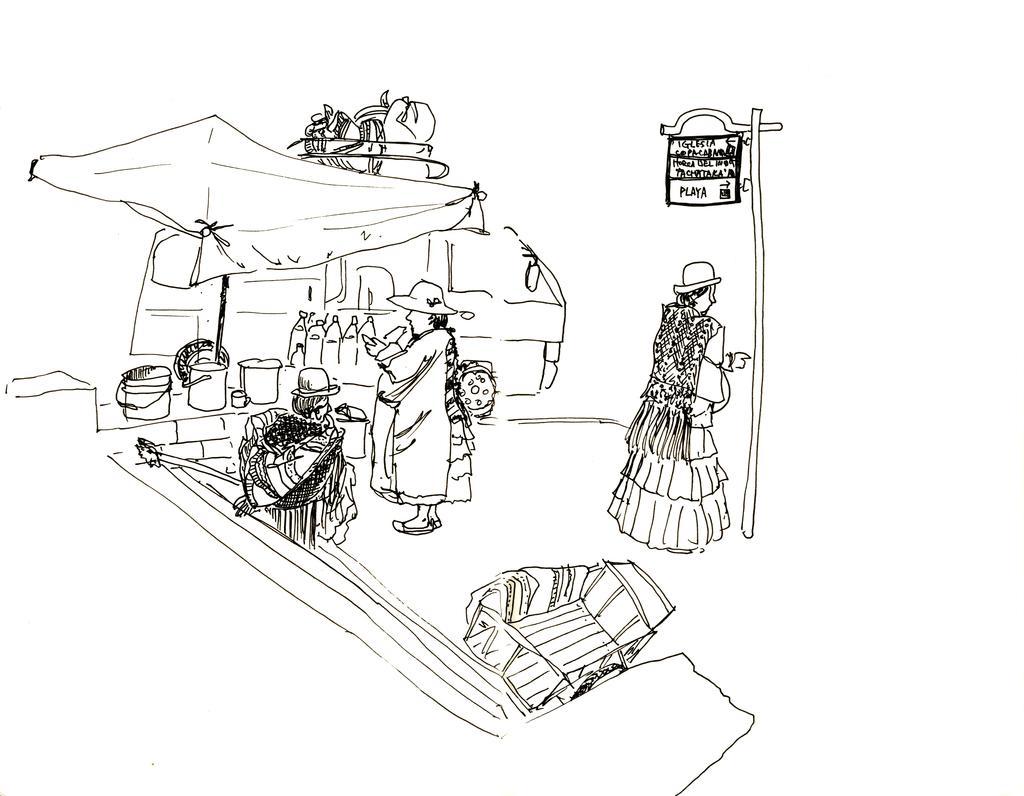Can you describe this image briefly? In the picture we can see a drawing of a two women are standing, one woman is standing near the pole with board, beside it, we can see another woman standing near the desk, on it we can see some things are placed and behind it we can see a van and some things are placed on the top of it. 